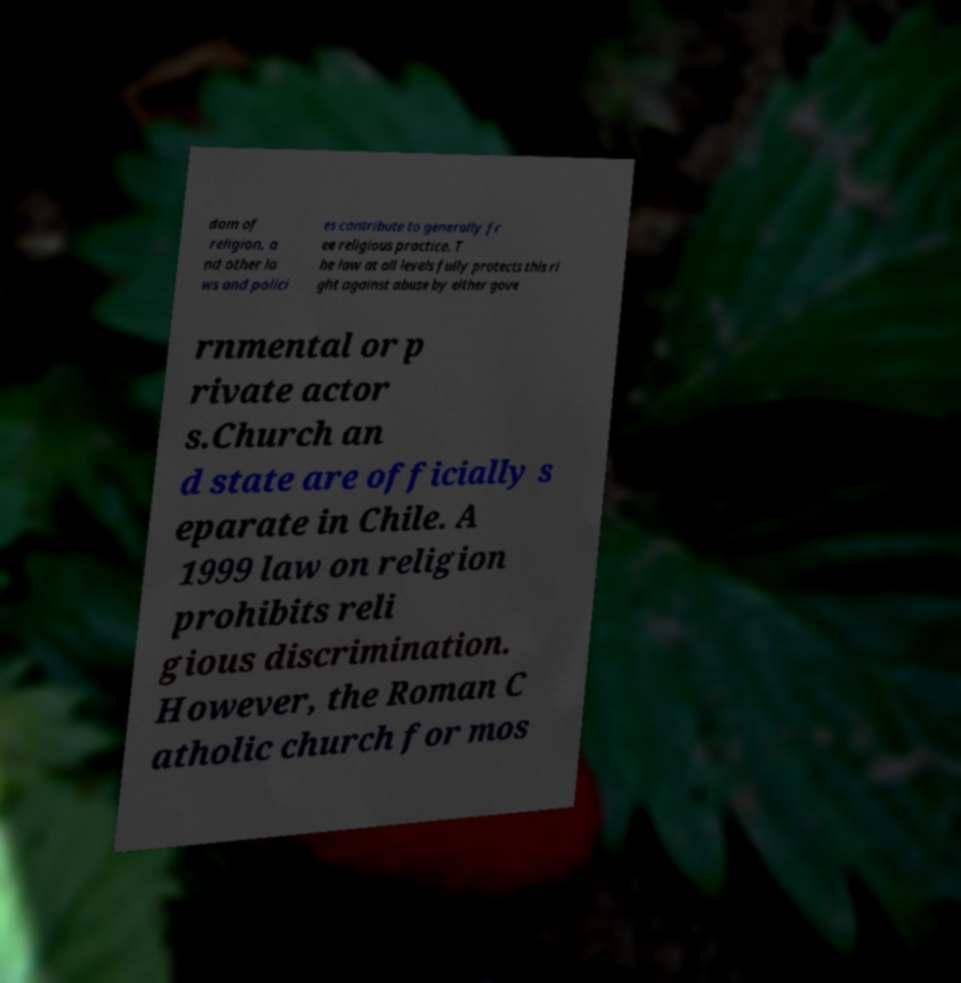Could you assist in decoding the text presented in this image and type it out clearly? dom of religion, a nd other la ws and polici es contribute to generally fr ee religious practice. T he law at all levels fully protects this ri ght against abuse by either gove rnmental or p rivate actor s.Church an d state are officially s eparate in Chile. A 1999 law on religion prohibits reli gious discrimination. However, the Roman C atholic church for mos 